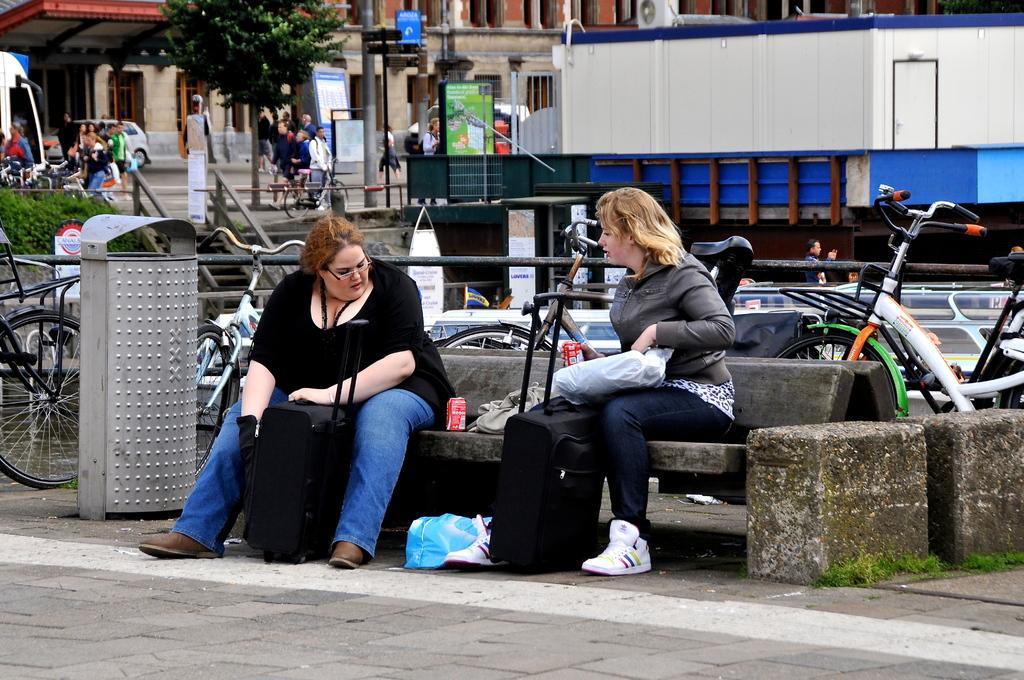Describe this image in one or two sentences. In this picture we can see suitcases, tins, bin, bicycles, plastic cover, two women sitting on a bench and at the back of them we can see plants, boards, container, stand, poles, tree, vehicles and a group of people and some objects and in the background we can see a building with windows. 